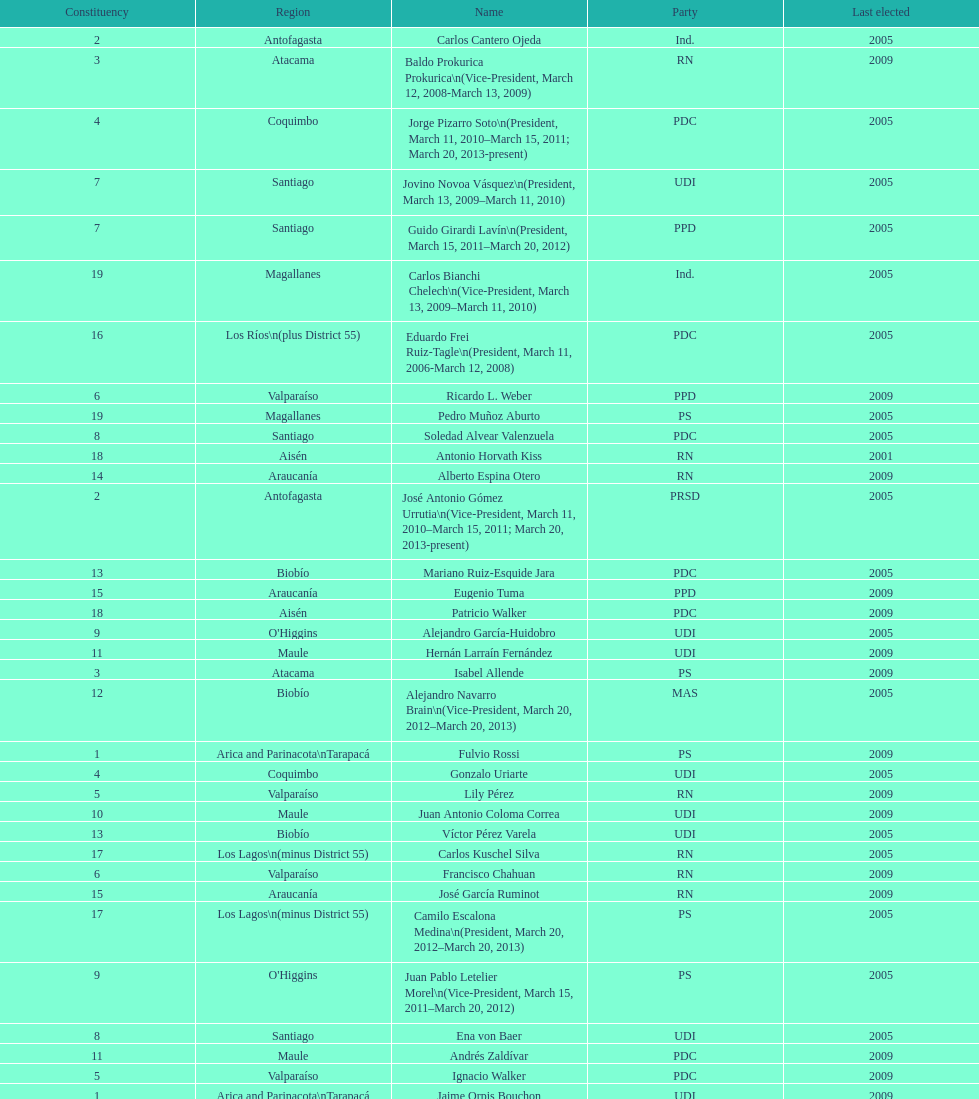What is the first name on the table? Fulvio Rossi. 